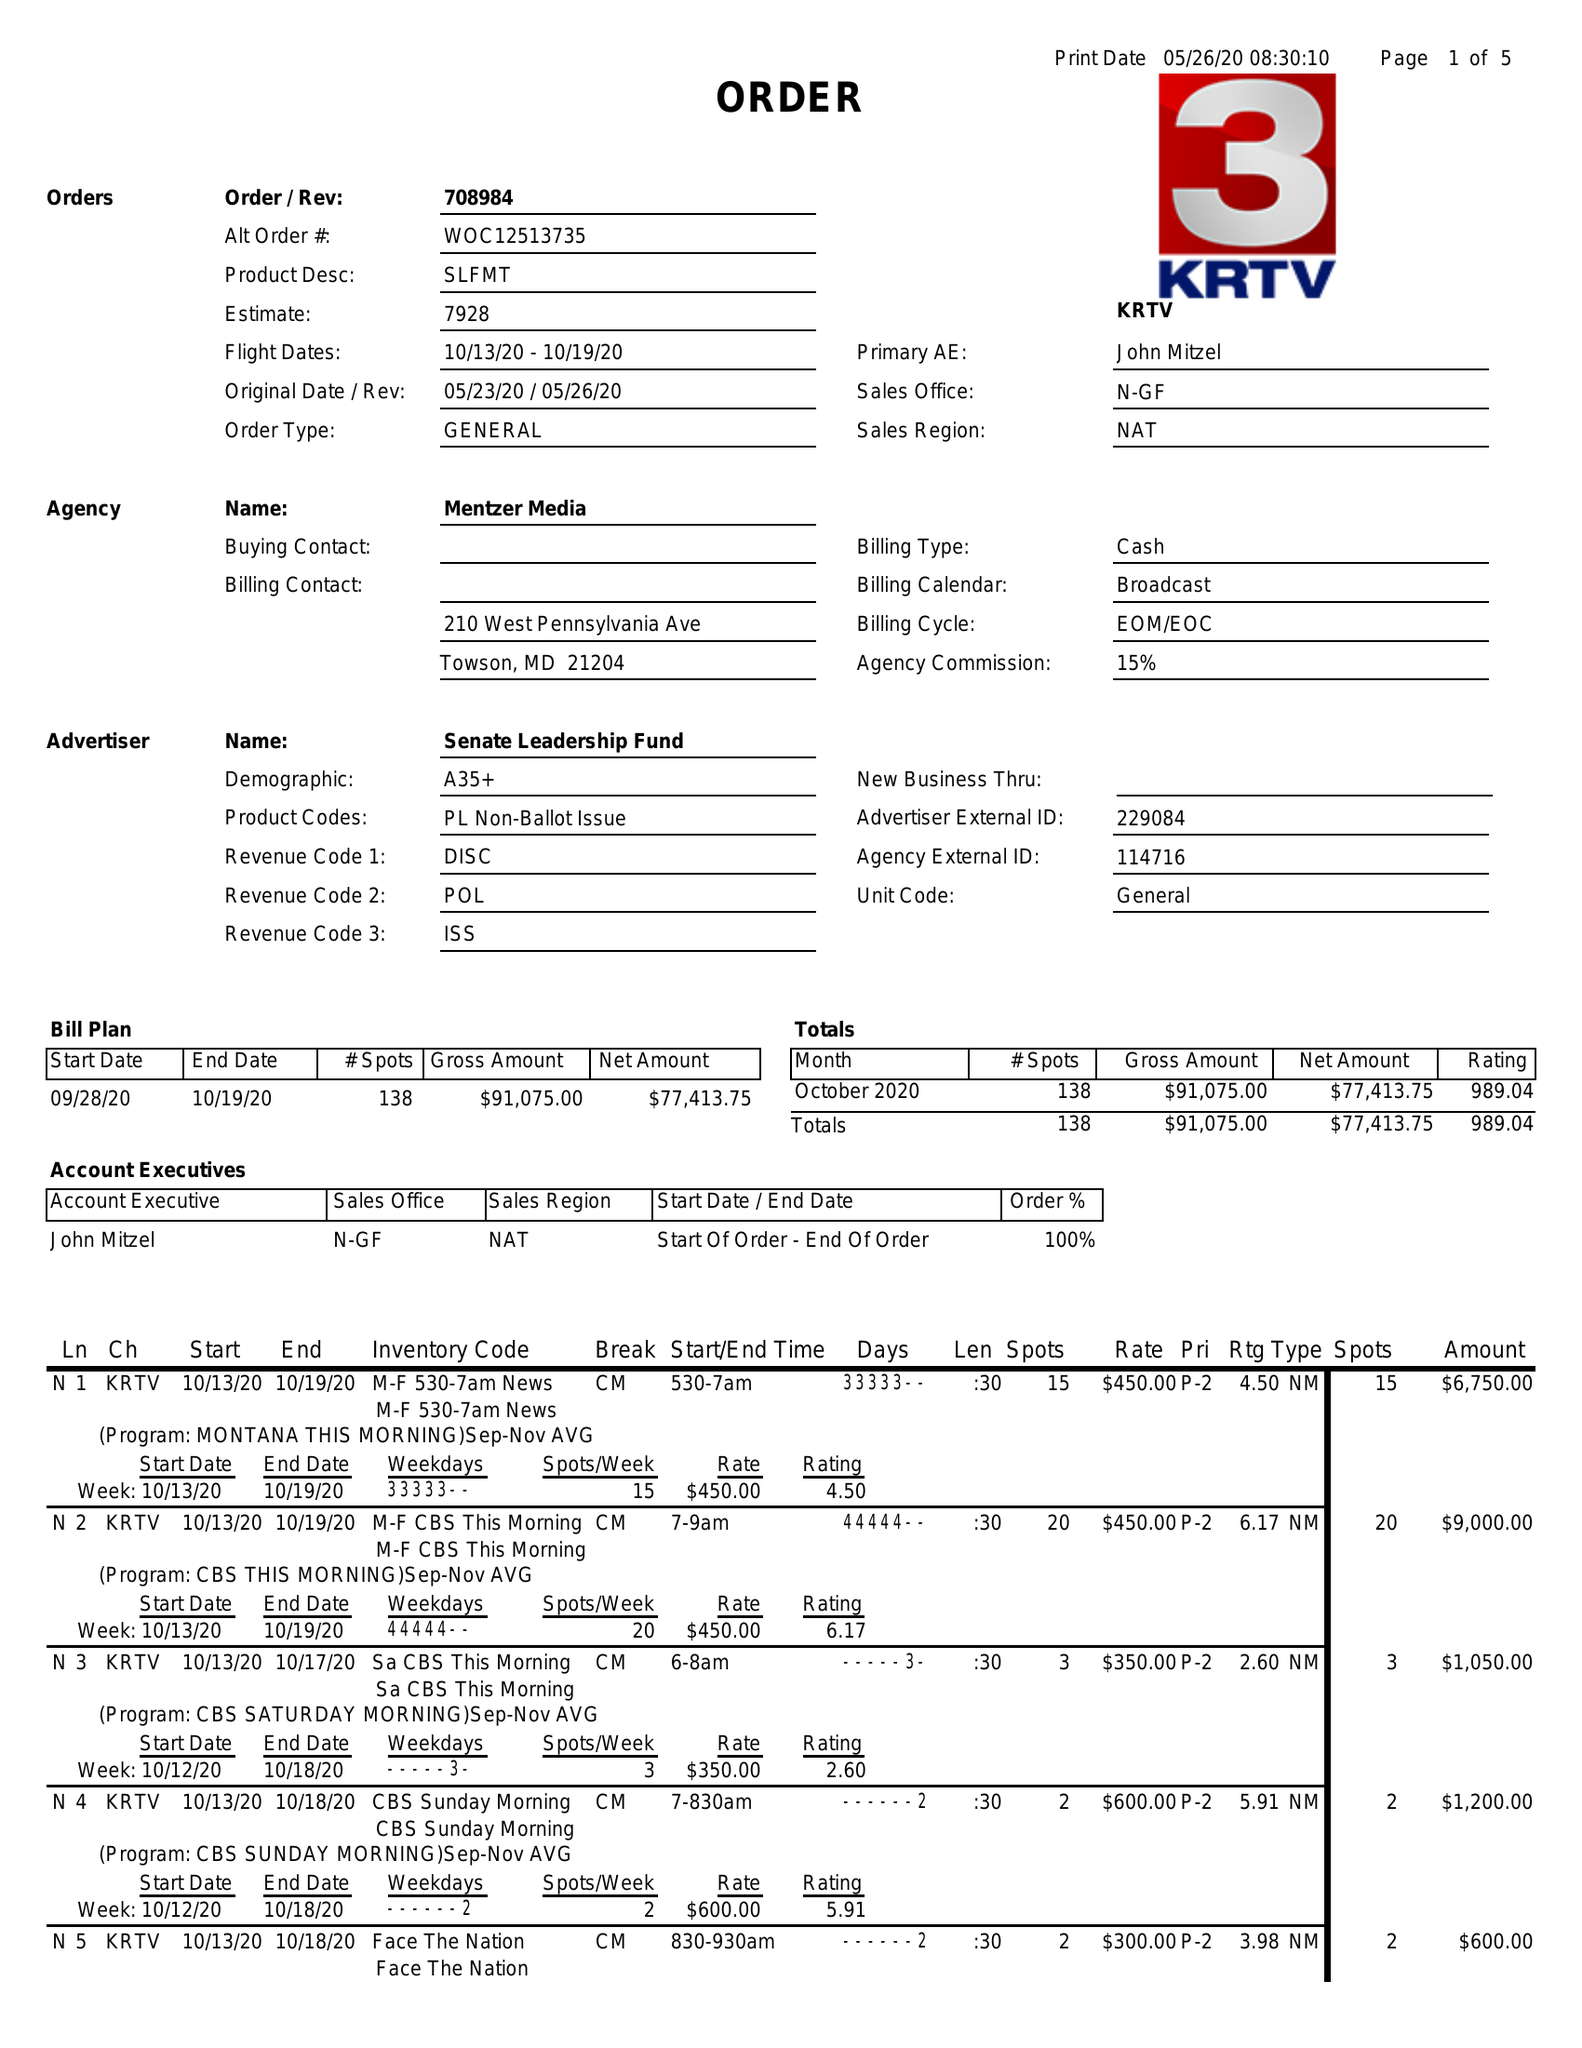What is the value for the flight_to?
Answer the question using a single word or phrase. 10/19/20 